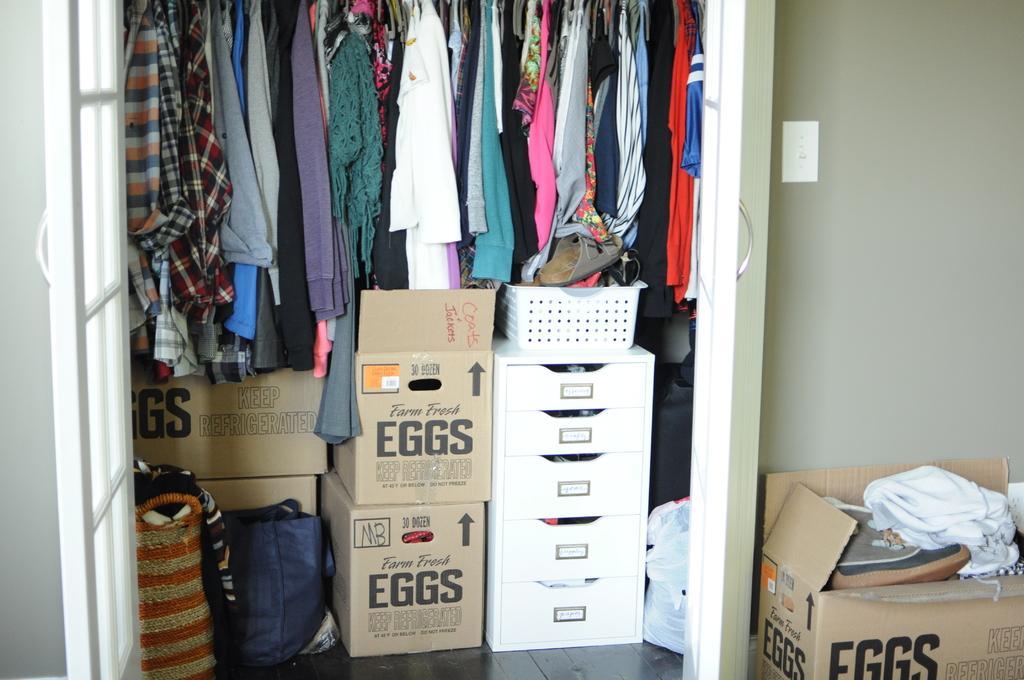Can you describe this image briefly? There are a lot of clothes and many boxes kept inside the wardrobe and there is another box beside the wardrobe and in the background there is a wall. 